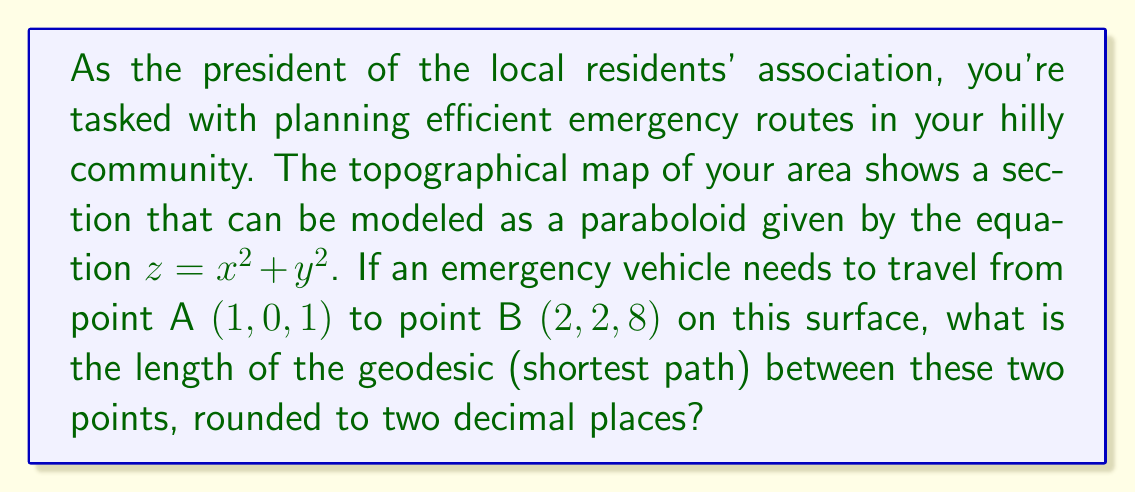Help me with this question. To solve this problem, we'll follow these steps:

1) The geodesic on a paraboloid is not a straight line in 3D space, but it can be found using differential geometry. However, for this specific case, we can use a shortcut.

2) For a paraboloid of the form $z = ax^2 + ay^2$, the geodesic between two points projects onto a straight line in the xy-plane.

3) In our case, $a = 1$, so we have $z = x^2 + y^2$.

4) Let's find the straight line in the xy-plane between the projections of points A and B:
   A: $(1, 0)$, B: $(2, 2)$

5) The length of this line in the xy-plane is:
   $$d_{xy} = \sqrt{(2-1)^2 + (2-0)^2} = \sqrt{5}$$

6) Now, we need to integrate along this line to find the actual length on the surface. The parametric equations of the line are:
   $x(t) = 1 + t$
   $y(t) = 2t$
   where $0 \leq t \leq 1$

7) The formula for the length of a curve on the surface $z = f(x,y)$ is:
   $$L = \int_0^1 \sqrt{1 + (\frac{\partial f}{\partial x})^2(\frac{dx}{dt})^2 + (\frac{\partial f}{\partial y})^2(\frac{dy}{dt})^2 + 2(\frac{\partial f}{\partial x})(\frac{\partial f}{\partial y})(\frac{dx}{dt})(\frac{dy}{dt})} dt$$

8) In our case:
   $\frac{\partial f}{\partial x} = 2x$, $\frac{\partial f}{\partial y} = 2y$
   $\frac{dx}{dt} = 1$, $\frac{dy}{dt} = 2$

9) Substituting these into the formula:
   $$L = \int_0^1 \sqrt{1 + (2(1+t))^2(1)^2 + (2(2t))^2(2)^2 + 2(2(1+t))(2(2t))(1)(2)} dt$$

10) Simplifying:
    $$L = \int_0^1 \sqrt{1 + 4(1+t)^2 + 64t^2 + 32t(1+t)} dt$$
    $$= \int_0^1 \sqrt{1 + 4 + 8t + 4t^2 + 64t^2 + 32t + 32t^2} dt$$
    $$= \int_0^1 \sqrt{5 + 40t + 100t^2} dt$$

11) This integral doesn't have a simple analytical solution, so we need to use numerical integration.

12) Using a numerical integration method (like Simpson's rule or a computer algebra system), we get:
    $$L \approx 3.7804$$

13) Rounding to two decimal places: 3.78
Answer: 3.78 